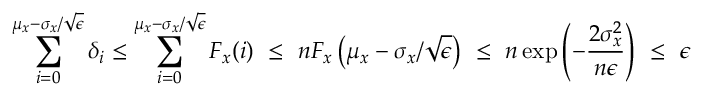Convert formula to latex. <formula><loc_0><loc_0><loc_500><loc_500>\sum _ { i = 0 } ^ { \mu _ { x } - \sigma _ { x } / \sqrt { \epsilon } } \delta _ { i } \leq \sum _ { i = 0 } ^ { \mu _ { x } - \sigma _ { x } / \sqrt { \epsilon } } F _ { x } ( i ) \ \leq \ n F _ { x } \left ( \mu _ { x } - \sigma _ { x } / \sqrt { \epsilon } \right ) \ \leq \ n \exp \left ( - \frac { 2 \sigma _ { x } ^ { 2 } } { n \epsilon } \right ) \ \leq \ \epsilon</formula> 